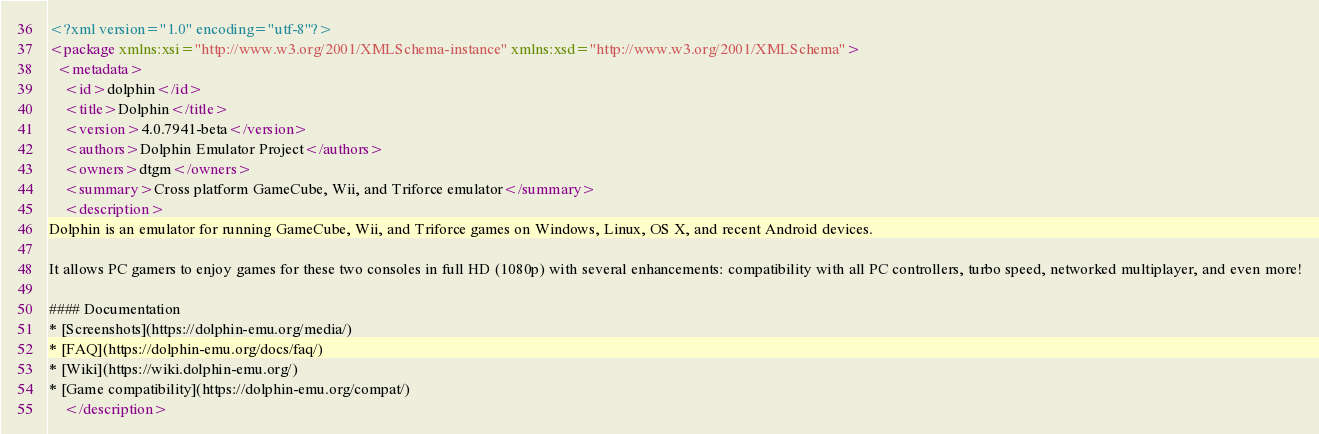<code> <loc_0><loc_0><loc_500><loc_500><_XML_><?xml version="1.0" encoding="utf-8"?>
<package xmlns:xsi="http://www.w3.org/2001/XMLSchema-instance" xmlns:xsd="http://www.w3.org/2001/XMLSchema">
  <metadata>
    <id>dolphin</id>
    <title>Dolphin</title>
    <version>4.0.7941-beta</version>
    <authors>Dolphin Emulator Project</authors>
    <owners>dtgm</owners>
    <summary>Cross platform GameCube, Wii, and Triforce emulator</summary>
    <description>
Dolphin is an emulator for running GameCube, Wii, and Triforce games on Windows, Linux, OS X, and recent Android devices.

It allows PC gamers to enjoy games for these two consoles in full HD (1080p) with several enhancements: compatibility with all PC controllers, turbo speed, networked multiplayer, and even more!

#### Documentation
* [Screenshots](https://dolphin-emu.org/media/)
* [FAQ](https://dolphin-emu.org/docs/faq/)
* [Wiki](https://wiki.dolphin-emu.org/)
* [Game compatibility](https://dolphin-emu.org/compat/)
    </description></code> 